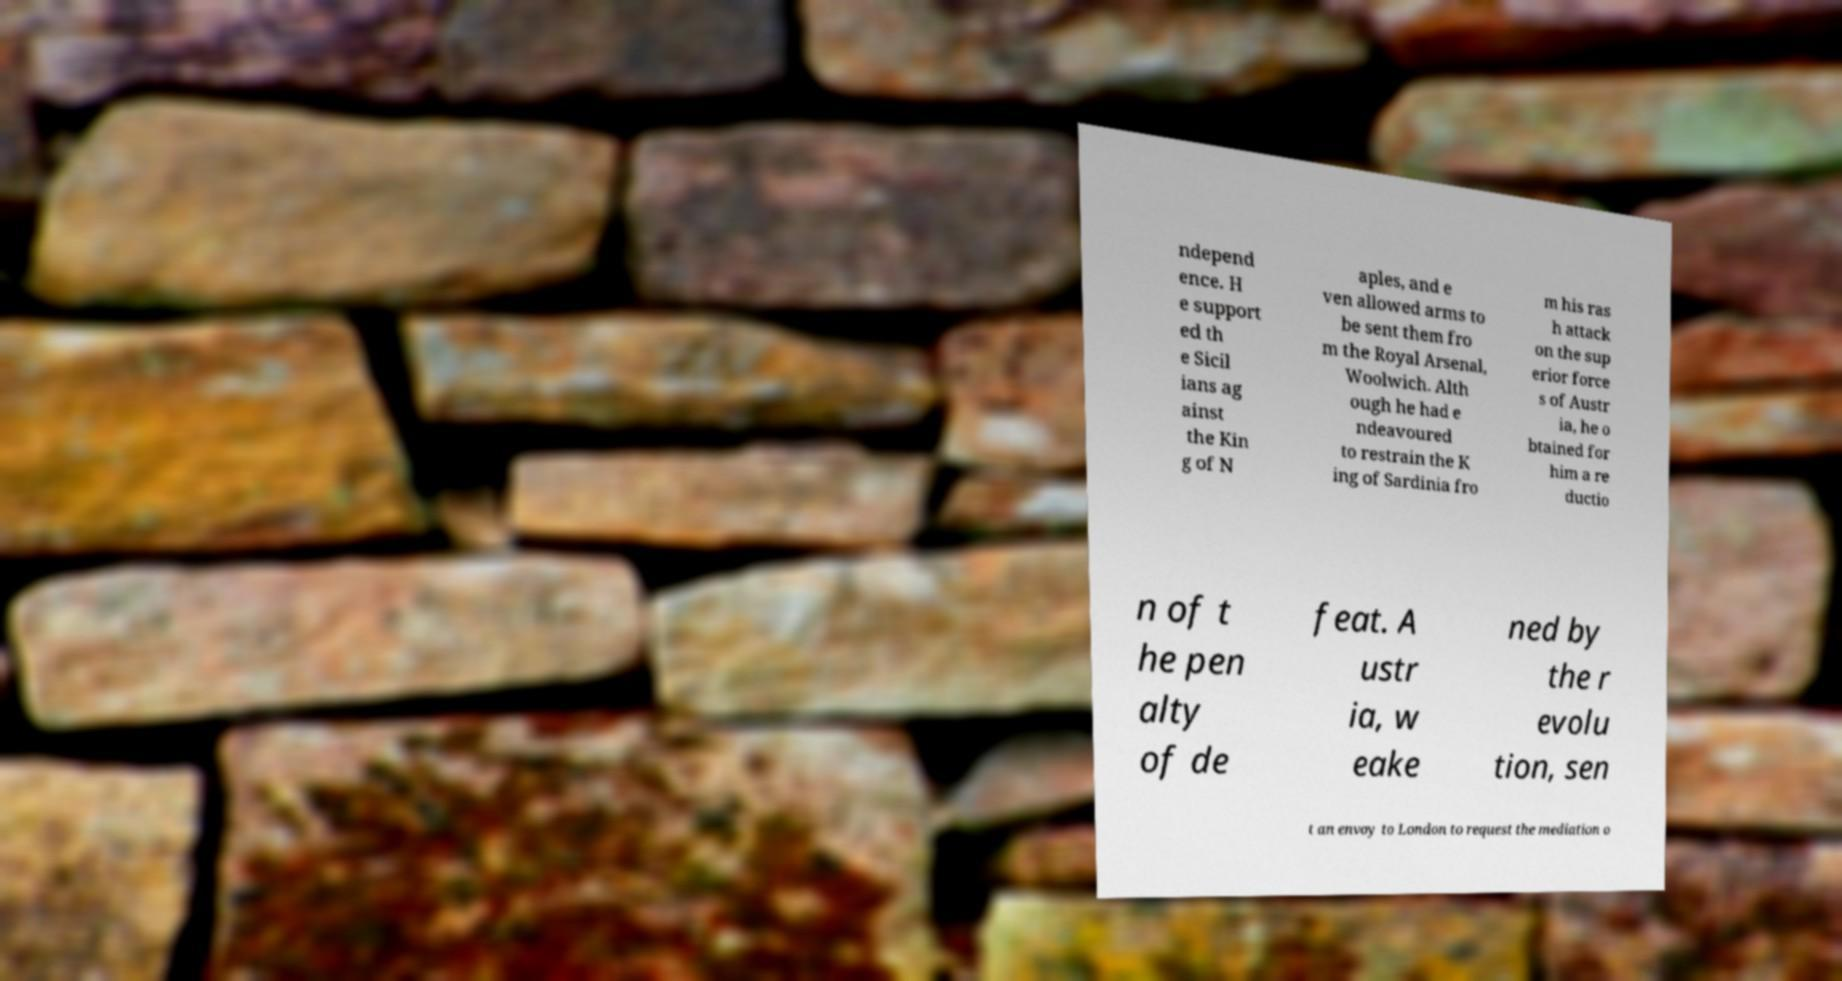There's text embedded in this image that I need extracted. Can you transcribe it verbatim? ndepend ence. H e support ed th e Sicil ians ag ainst the Kin g of N aples, and e ven allowed arms to be sent them fro m the Royal Arsenal, Woolwich. Alth ough he had e ndeavoured to restrain the K ing of Sardinia fro m his ras h attack on the sup erior force s of Austr ia, he o btained for him a re ductio n of t he pen alty of de feat. A ustr ia, w eake ned by the r evolu tion, sen t an envoy to London to request the mediation o 